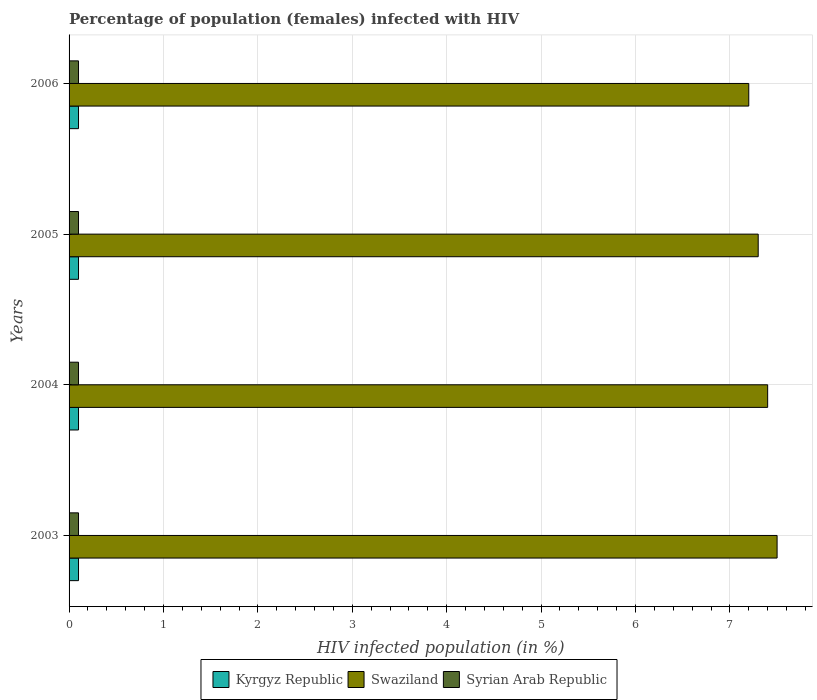How many groups of bars are there?
Your response must be concise. 4. Are the number of bars per tick equal to the number of legend labels?
Ensure brevity in your answer.  Yes. How many bars are there on the 3rd tick from the top?
Your response must be concise. 3. How many bars are there on the 3rd tick from the bottom?
Provide a succinct answer. 3. Across all years, what is the maximum percentage of HIV infected female population in Kyrgyz Republic?
Provide a short and direct response. 0.1. Across all years, what is the minimum percentage of HIV infected female population in Swaziland?
Offer a very short reply. 7.2. In which year was the percentage of HIV infected female population in Swaziland maximum?
Offer a terse response. 2003. What is the total percentage of HIV infected female population in Swaziland in the graph?
Provide a short and direct response. 29.4. What is the difference between the percentage of HIV infected female population in Swaziland in 2003 and that in 2006?
Your answer should be very brief. 0.3. In the year 2006, what is the difference between the percentage of HIV infected female population in Kyrgyz Republic and percentage of HIV infected female population in Swaziland?
Keep it short and to the point. -7.1. What is the ratio of the percentage of HIV infected female population in Swaziland in 2004 to that in 2006?
Ensure brevity in your answer.  1.03. In how many years, is the percentage of HIV infected female population in Kyrgyz Republic greater than the average percentage of HIV infected female population in Kyrgyz Republic taken over all years?
Your answer should be very brief. 0. What does the 2nd bar from the top in 2004 represents?
Provide a short and direct response. Swaziland. What does the 1st bar from the bottom in 2003 represents?
Give a very brief answer. Kyrgyz Republic. How many bars are there?
Ensure brevity in your answer.  12. How many years are there in the graph?
Your answer should be very brief. 4. What is the difference between two consecutive major ticks on the X-axis?
Ensure brevity in your answer.  1. Does the graph contain any zero values?
Provide a short and direct response. No. How are the legend labels stacked?
Give a very brief answer. Horizontal. What is the title of the graph?
Provide a succinct answer. Percentage of population (females) infected with HIV. What is the label or title of the X-axis?
Provide a succinct answer. HIV infected population (in %). What is the label or title of the Y-axis?
Give a very brief answer. Years. What is the HIV infected population (in %) in Kyrgyz Republic in 2003?
Give a very brief answer. 0.1. What is the HIV infected population (in %) of Swaziland in 2005?
Offer a very short reply. 7.3. What is the HIV infected population (in %) in Syrian Arab Republic in 2005?
Make the answer very short. 0.1. What is the HIV infected population (in %) in Kyrgyz Republic in 2006?
Offer a very short reply. 0.1. Across all years, what is the maximum HIV infected population (in %) in Syrian Arab Republic?
Provide a short and direct response. 0.1. Across all years, what is the minimum HIV infected population (in %) in Swaziland?
Your answer should be very brief. 7.2. Across all years, what is the minimum HIV infected population (in %) of Syrian Arab Republic?
Your answer should be compact. 0.1. What is the total HIV infected population (in %) in Kyrgyz Republic in the graph?
Provide a short and direct response. 0.4. What is the total HIV infected population (in %) of Swaziland in the graph?
Give a very brief answer. 29.4. What is the difference between the HIV infected population (in %) in Kyrgyz Republic in 2003 and that in 2004?
Give a very brief answer. 0. What is the difference between the HIV infected population (in %) of Swaziland in 2003 and that in 2004?
Give a very brief answer. 0.1. What is the difference between the HIV infected population (in %) of Swaziland in 2003 and that in 2005?
Offer a terse response. 0.2. What is the difference between the HIV infected population (in %) in Kyrgyz Republic in 2003 and that in 2006?
Make the answer very short. 0. What is the difference between the HIV infected population (in %) of Swaziland in 2003 and that in 2006?
Make the answer very short. 0.3. What is the difference between the HIV infected population (in %) of Syrian Arab Republic in 2003 and that in 2006?
Offer a terse response. 0. What is the difference between the HIV infected population (in %) in Kyrgyz Republic in 2004 and that in 2005?
Ensure brevity in your answer.  0. What is the difference between the HIV infected population (in %) in Swaziland in 2004 and that in 2005?
Provide a succinct answer. 0.1. What is the difference between the HIV infected population (in %) in Syrian Arab Republic in 2004 and that in 2006?
Give a very brief answer. 0. What is the difference between the HIV infected population (in %) in Kyrgyz Republic in 2003 and the HIV infected population (in %) in Swaziland in 2004?
Give a very brief answer. -7.3. What is the difference between the HIV infected population (in %) in Kyrgyz Republic in 2003 and the HIV infected population (in %) in Swaziland in 2005?
Provide a succinct answer. -7.2. What is the difference between the HIV infected population (in %) in Kyrgyz Republic in 2003 and the HIV infected population (in %) in Swaziland in 2006?
Provide a succinct answer. -7.1. What is the difference between the HIV infected population (in %) in Swaziland in 2003 and the HIV infected population (in %) in Syrian Arab Republic in 2006?
Your answer should be very brief. 7.4. What is the difference between the HIV infected population (in %) of Kyrgyz Republic in 2004 and the HIV infected population (in %) of Swaziland in 2005?
Make the answer very short. -7.2. What is the difference between the HIV infected population (in %) of Kyrgyz Republic in 2004 and the HIV infected population (in %) of Syrian Arab Republic in 2005?
Provide a succinct answer. 0. What is the difference between the HIV infected population (in %) of Swaziland in 2004 and the HIV infected population (in %) of Syrian Arab Republic in 2005?
Keep it short and to the point. 7.3. What is the difference between the HIV infected population (in %) in Kyrgyz Republic in 2005 and the HIV infected population (in %) in Syrian Arab Republic in 2006?
Keep it short and to the point. 0. What is the difference between the HIV infected population (in %) in Swaziland in 2005 and the HIV infected population (in %) in Syrian Arab Republic in 2006?
Make the answer very short. 7.2. What is the average HIV infected population (in %) of Swaziland per year?
Provide a short and direct response. 7.35. What is the average HIV infected population (in %) of Syrian Arab Republic per year?
Your answer should be very brief. 0.1. In the year 2003, what is the difference between the HIV infected population (in %) of Kyrgyz Republic and HIV infected population (in %) of Syrian Arab Republic?
Make the answer very short. 0. In the year 2003, what is the difference between the HIV infected population (in %) of Swaziland and HIV infected population (in %) of Syrian Arab Republic?
Offer a terse response. 7.4. In the year 2004, what is the difference between the HIV infected population (in %) in Kyrgyz Republic and HIV infected population (in %) in Swaziland?
Give a very brief answer. -7.3. In the year 2004, what is the difference between the HIV infected population (in %) in Swaziland and HIV infected population (in %) in Syrian Arab Republic?
Offer a terse response. 7.3. In the year 2005, what is the difference between the HIV infected population (in %) of Kyrgyz Republic and HIV infected population (in %) of Swaziland?
Ensure brevity in your answer.  -7.2. In the year 2005, what is the difference between the HIV infected population (in %) in Swaziland and HIV infected population (in %) in Syrian Arab Republic?
Provide a short and direct response. 7.2. In the year 2006, what is the difference between the HIV infected population (in %) in Kyrgyz Republic and HIV infected population (in %) in Swaziland?
Your response must be concise. -7.1. In the year 2006, what is the difference between the HIV infected population (in %) in Kyrgyz Republic and HIV infected population (in %) in Syrian Arab Republic?
Ensure brevity in your answer.  0. What is the ratio of the HIV infected population (in %) in Swaziland in 2003 to that in 2004?
Make the answer very short. 1.01. What is the ratio of the HIV infected population (in %) of Syrian Arab Republic in 2003 to that in 2004?
Offer a terse response. 1. What is the ratio of the HIV infected population (in %) in Kyrgyz Republic in 2003 to that in 2005?
Your answer should be very brief. 1. What is the ratio of the HIV infected population (in %) in Swaziland in 2003 to that in 2005?
Offer a terse response. 1.03. What is the ratio of the HIV infected population (in %) of Syrian Arab Republic in 2003 to that in 2005?
Your response must be concise. 1. What is the ratio of the HIV infected population (in %) of Kyrgyz Republic in 2003 to that in 2006?
Ensure brevity in your answer.  1. What is the ratio of the HIV infected population (in %) in Swaziland in 2003 to that in 2006?
Your response must be concise. 1.04. What is the ratio of the HIV infected population (in %) in Syrian Arab Republic in 2003 to that in 2006?
Your answer should be compact. 1. What is the ratio of the HIV infected population (in %) of Swaziland in 2004 to that in 2005?
Make the answer very short. 1.01. What is the ratio of the HIV infected population (in %) of Kyrgyz Republic in 2004 to that in 2006?
Keep it short and to the point. 1. What is the ratio of the HIV infected population (in %) of Swaziland in 2004 to that in 2006?
Offer a very short reply. 1.03. What is the ratio of the HIV infected population (in %) of Swaziland in 2005 to that in 2006?
Make the answer very short. 1.01. What is the difference between the highest and the second highest HIV infected population (in %) of Kyrgyz Republic?
Offer a terse response. 0. What is the difference between the highest and the lowest HIV infected population (in %) in Syrian Arab Republic?
Give a very brief answer. 0. 